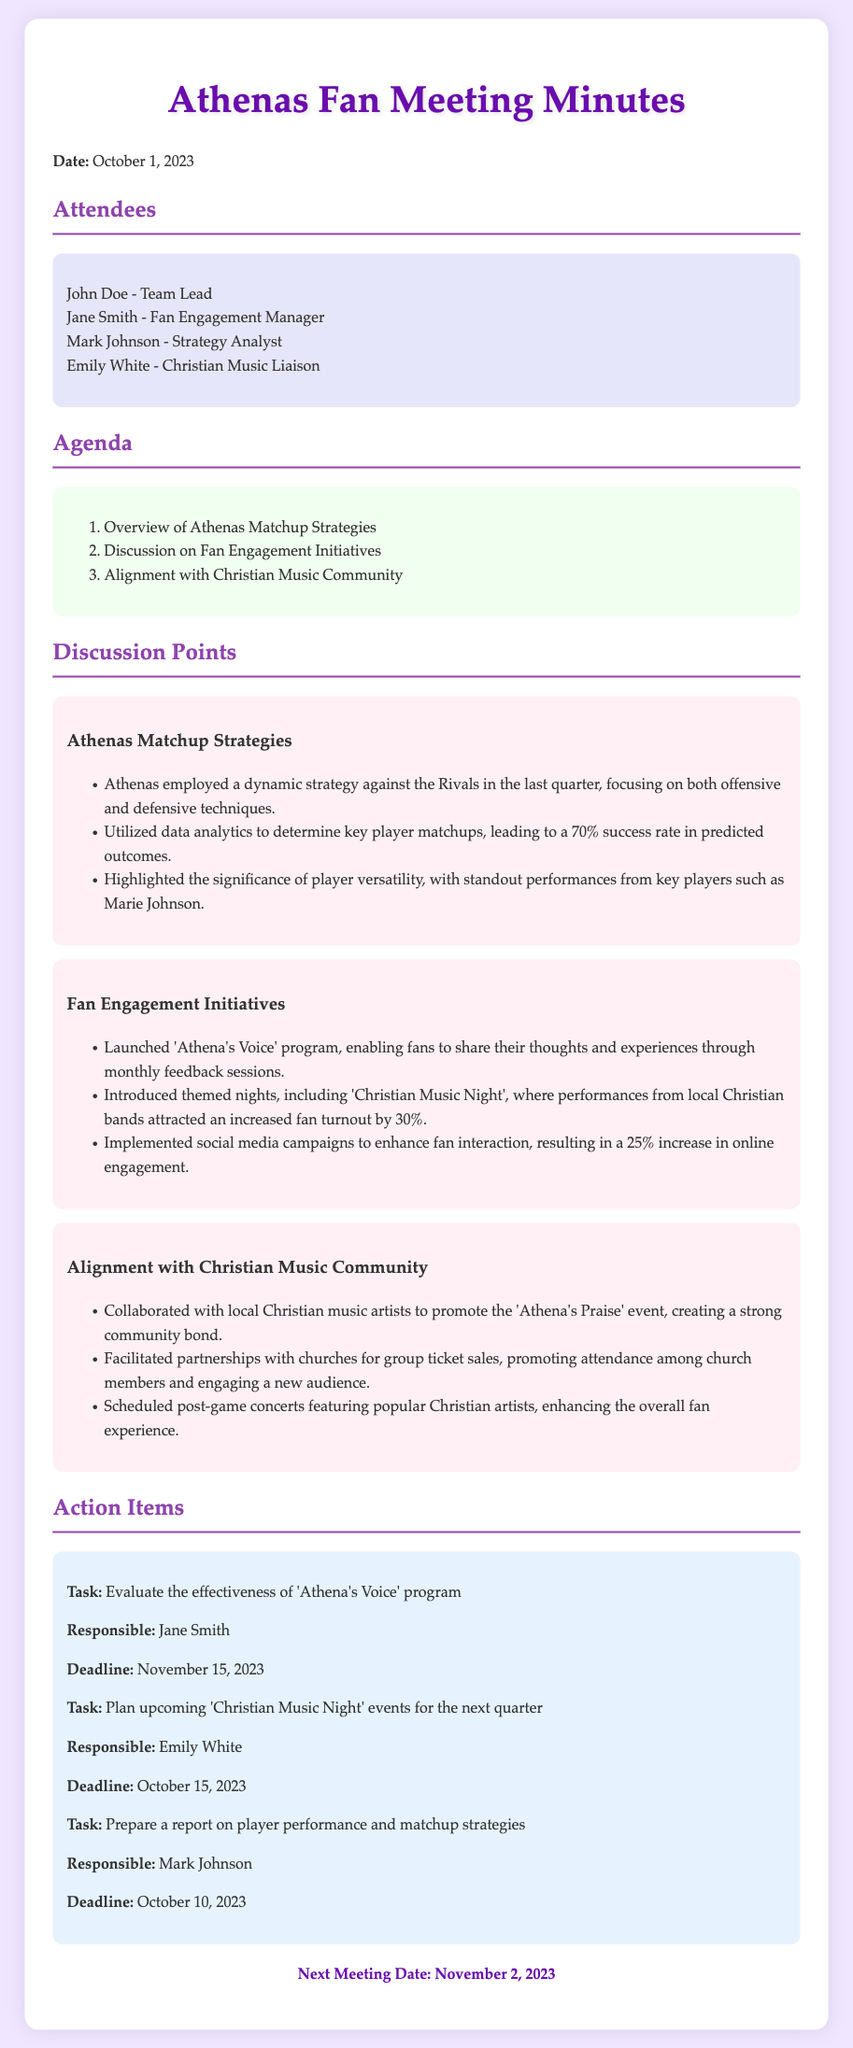What is the date of the meeting? The date of the meeting is explicitly mentioned at the beginning of the document.
Answer: October 1, 2023 Who is responsible for planning the upcoming Christian Music Night events? The document indicates the person assigned to this task in the action items section.
Answer: Emily White What was the increase in fan turnout for Christian Music Night? This information is provided in the discussion points under fan engagement initiatives.
Answer: 30% What is the name of the program enabling fans to share their thoughts? The program is discussed in the fan engagement initiatives section and is specifically named.
Answer: Athena's Voice What is the deadline for evaluating the effectiveness of 'Athena's Voice' program? The deadline is listed with the respective action item in the document.
Answer: November 15, 2023 How many attendees were listed at the meeting? The number of attendees is apparent from the attendees section of the document.
Answer: Four What strategy did Athenas employ against the Rivals? This refers to an overarching approach detailed in the matchup strategies section.
Answer: Dynamic strategy Which event was highlighted for collaboration with local Christian music artists? This specific event is mentioned under the alignment with the Christian music community.
Answer: Athena's Praise What is the next meeting date? The next meeting date is stated at the end of the document.
Answer: November 2, 2023 